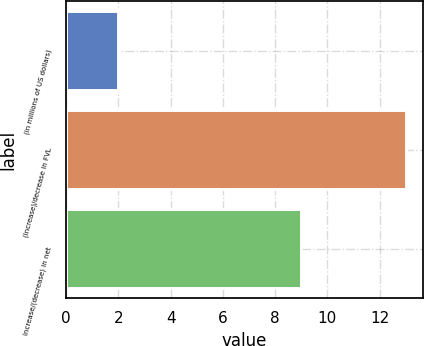Convert chart to OTSL. <chart><loc_0><loc_0><loc_500><loc_500><bar_chart><fcel>(in millions of US dollars)<fcel>(Increase)/decrease in FVL<fcel>Increase/(decrease) in net<nl><fcel>2<fcel>13<fcel>9<nl></chart> 